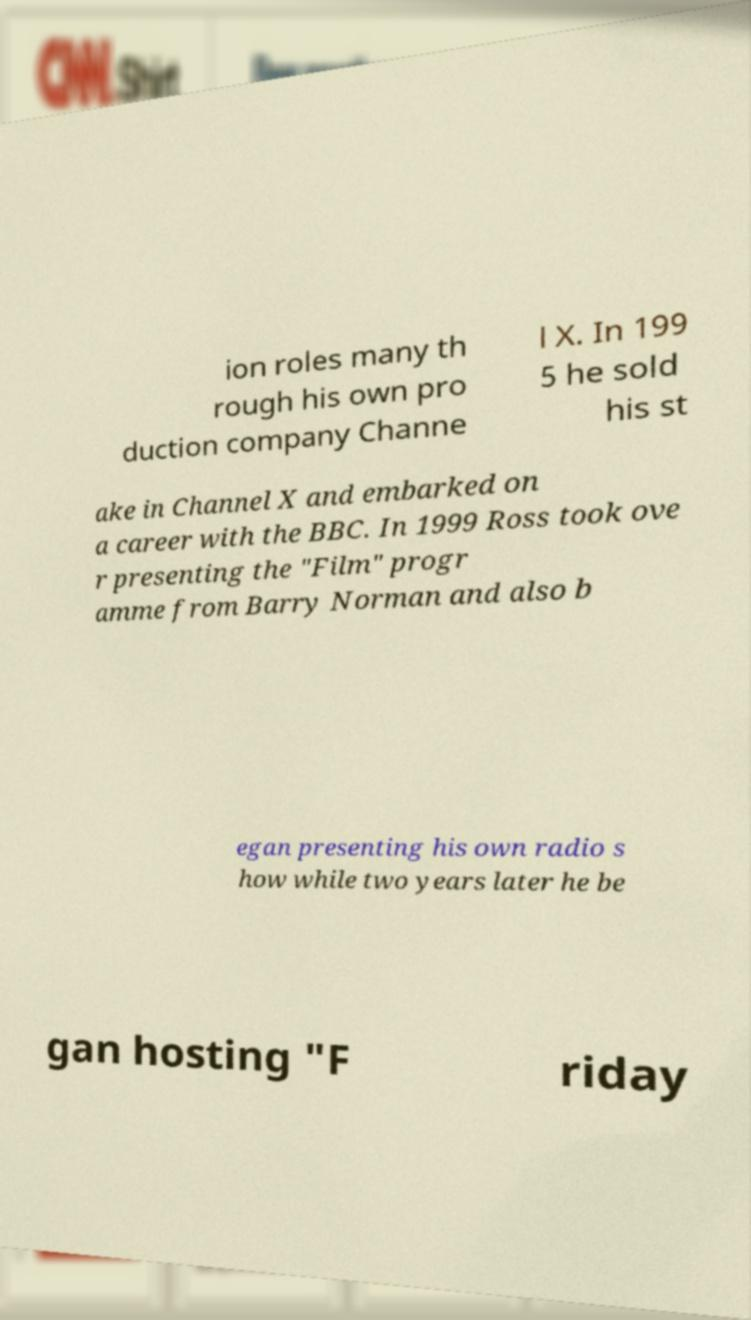What messages or text are displayed in this image? I need them in a readable, typed format. ion roles many th rough his own pro duction company Channe l X. In 199 5 he sold his st ake in Channel X and embarked on a career with the BBC. In 1999 Ross took ove r presenting the "Film" progr amme from Barry Norman and also b egan presenting his own radio s how while two years later he be gan hosting "F riday 